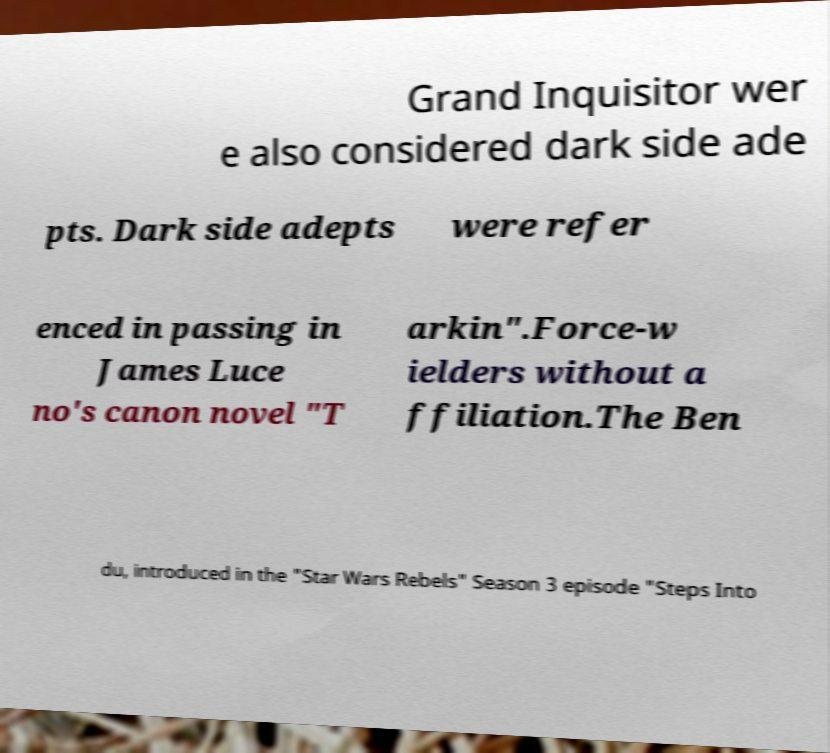For documentation purposes, I need the text within this image transcribed. Could you provide that? Grand Inquisitor wer e also considered dark side ade pts. Dark side adepts were refer enced in passing in James Luce no's canon novel "T arkin".Force-w ielders without a ffiliation.The Ben du, introduced in the "Star Wars Rebels" Season 3 episode "Steps Into 